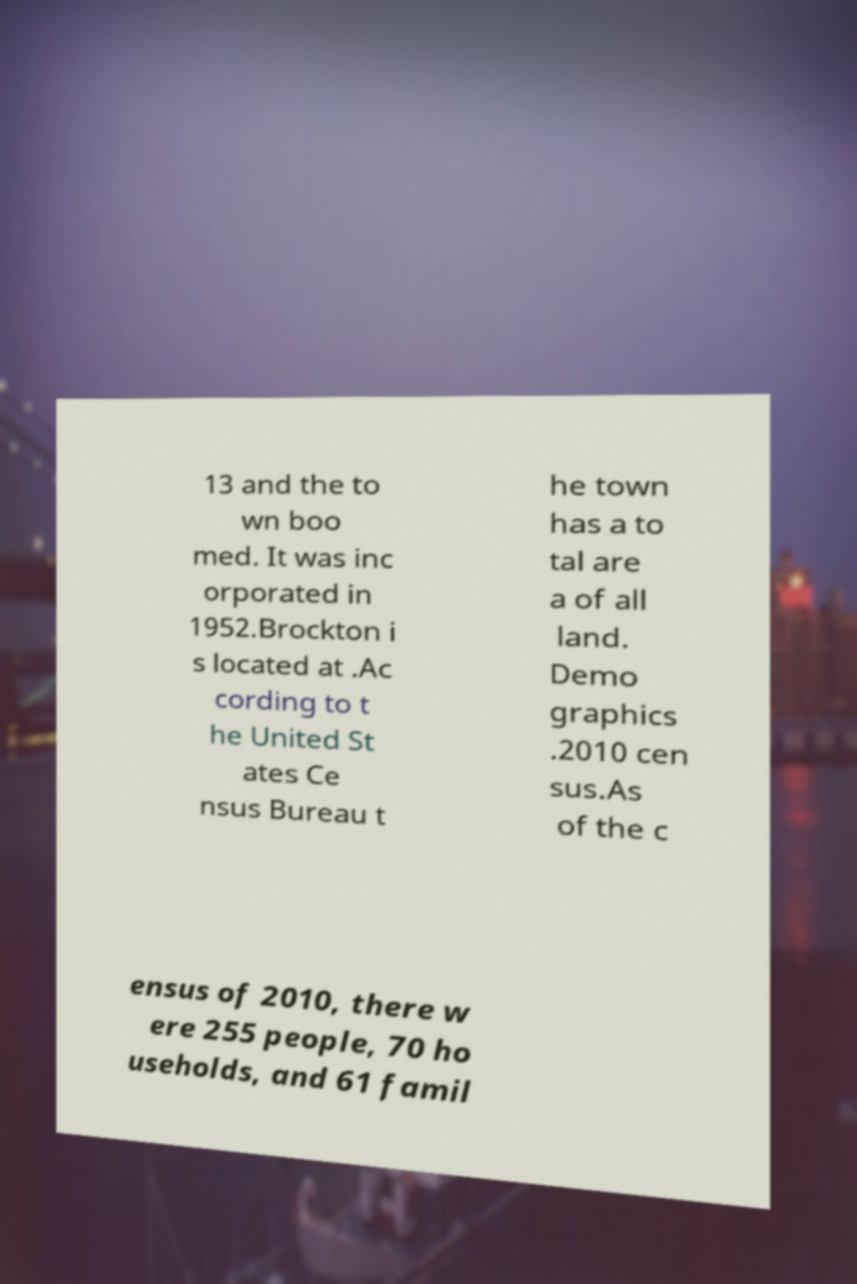Can you read and provide the text displayed in the image?This photo seems to have some interesting text. Can you extract and type it out for me? 13 and the to wn boo med. It was inc orporated in 1952.Brockton i s located at .Ac cording to t he United St ates Ce nsus Bureau t he town has a to tal are a of all land. Demo graphics .2010 cen sus.As of the c ensus of 2010, there w ere 255 people, 70 ho useholds, and 61 famil 